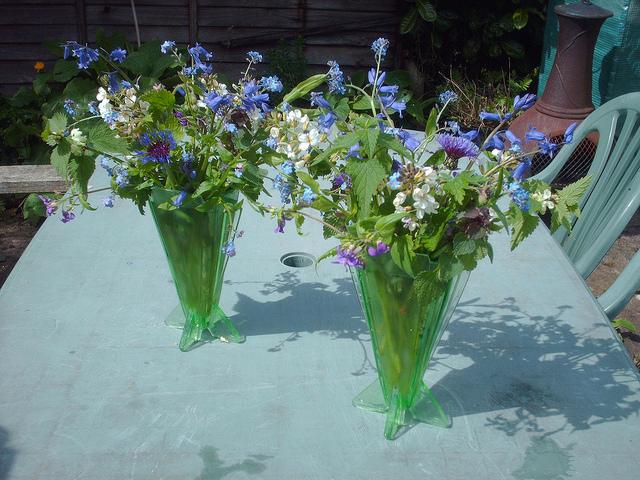Is there more than one vase filled with flowers on the table?
Answer briefly. Yes. How many vases on the table?
Answer briefly. 2. What color are the vases?
Give a very brief answer. Green. What color is are the flowers?
Quick response, please. Purple. 